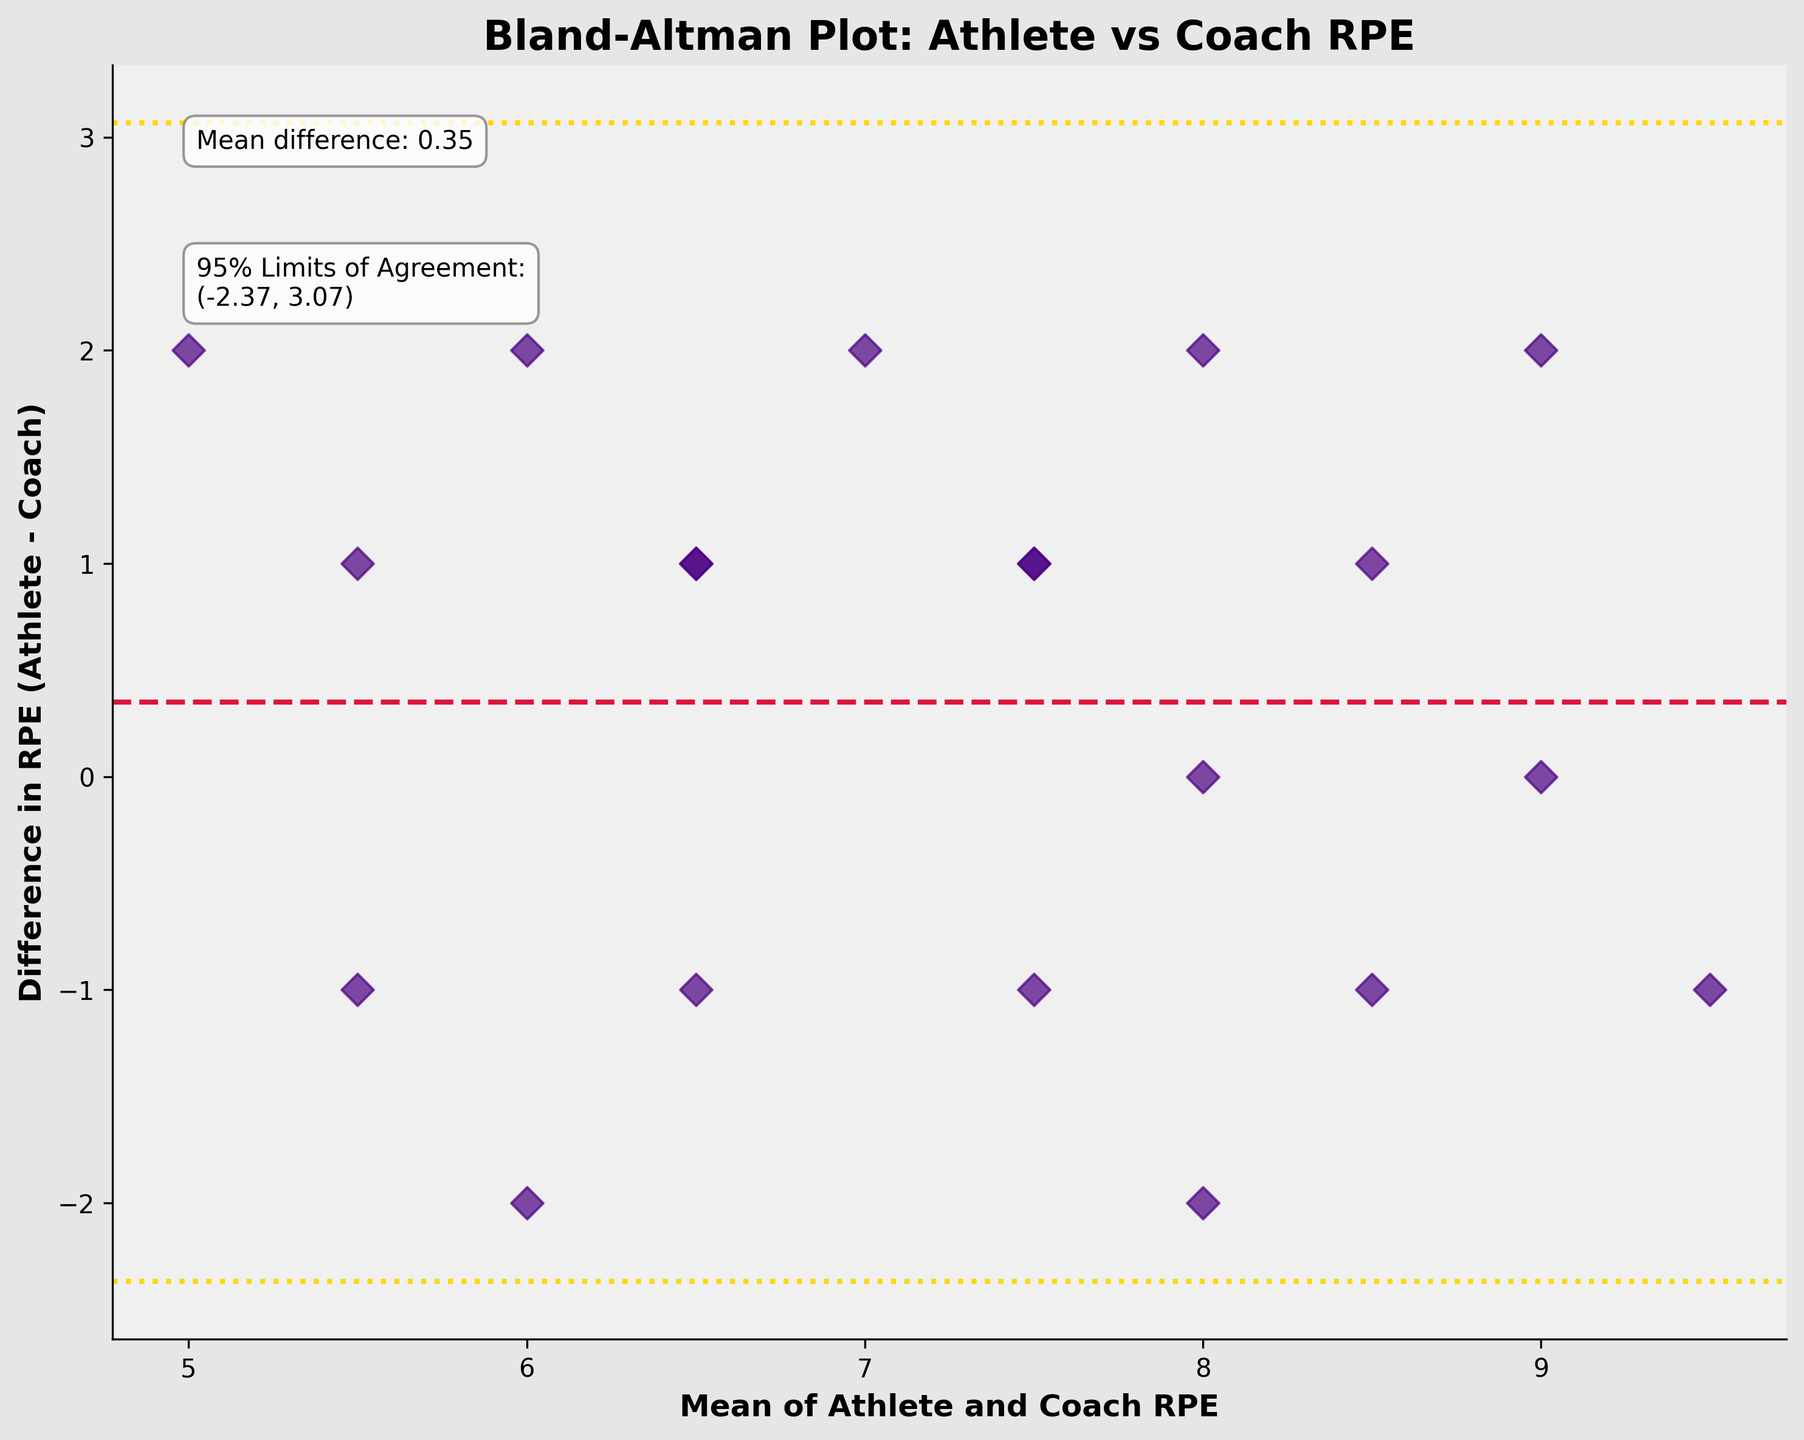What's the title of the plot? The title is displayed prominently at the top of the plot. In this case, the title reads "Bland-Altman Plot: Athlete vs Coach RPE" which indicates the type of plot and the variables being compared.
Answer: Bland-Altman Plot: Athlete vs Coach RPE What do the x-axis and y-axis represent? The labels on the x-axis and y-axis provide this information. The x-axis represents "Mean of Athlete and Coach RPE," and the y-axis represents "Difference in RPE (Athlete - Coach)."
Answer: Mean of Athlete and Coach RPE, Difference in RPE (Athlete - Coach) What color are the data points, and what shape do they have? The data points can be identified by their visual characteristics. In this case, they are colored indigo and shaped like diamonds (D).
Answer: Indigo, Diamonds How many data points are plotted in the figure? The number of data points can be counted visually from the plot. By counting each point, it is clear there are 20 data points in this plot.
Answer: 20 What is the mean difference between the athlete and coach RPE? The mean difference is annotated on the plot. The text near the top-left corner mentions "Mean difference: X.XX". In this plot, it states "Mean difference: 0.40."
Answer: 0.40 What are the 95% limits of agreement for the RPE differences? The upper and lower limits of agreement are annotated near the mean difference annotation. The limits are given by "95% Limits of Agreement: (lower_limit, upper_limit)". Here it is "(-1.85, 2.65)."
Answer: -1.85, 2.65 Which direction indicates a higher RPE rating from the athlete compared to the coach? The y-axis represents the difference (Athlete - Coach). Positive values indicate the athlete's RPE is higher than the coach's, and negative values indicate the opposite.
Answer: Positive direction How many points fall outside the 95% limits of agreement? To determine this, visually count the points that lie above the upper limit or below the lower limit. Here, three points fall outside the limits.
Answer: 3 What is the average of the overall RPE values for both the athlete and the coach? Calculate the mean of the mean RPE values shown on the x-axis. Sum up all mean RPEs for each point and divide by the number of points.
Answer: Around 7.5 (precise calculation with given data) 